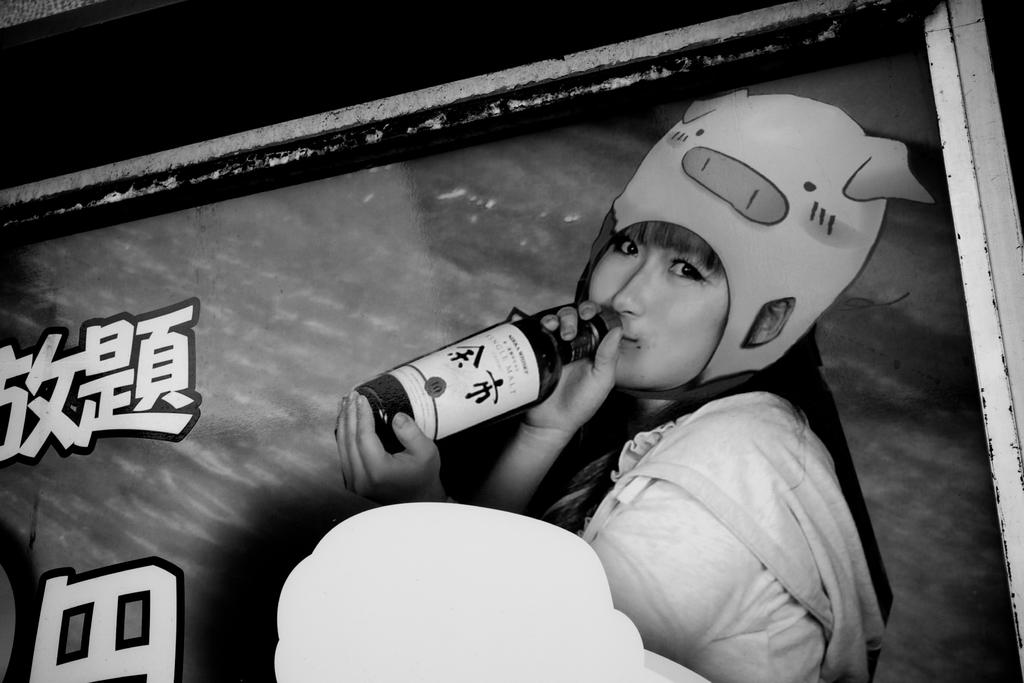Who or what is the main subject in the image? There is a person in the image. What can be observed about the person's attire? The person is wearing clothes. Is there any headwear visible on the person? Yes, the person is wearing a cap on her head. What object is the person holding in the image? The person is holding a bottle. What is the person's annual income in the image? There is no information about the person's income in the image. How does the wind affect the person's appearance in the image? There is no wind present in the image, so its effect on the person's appearance cannot be determined. 